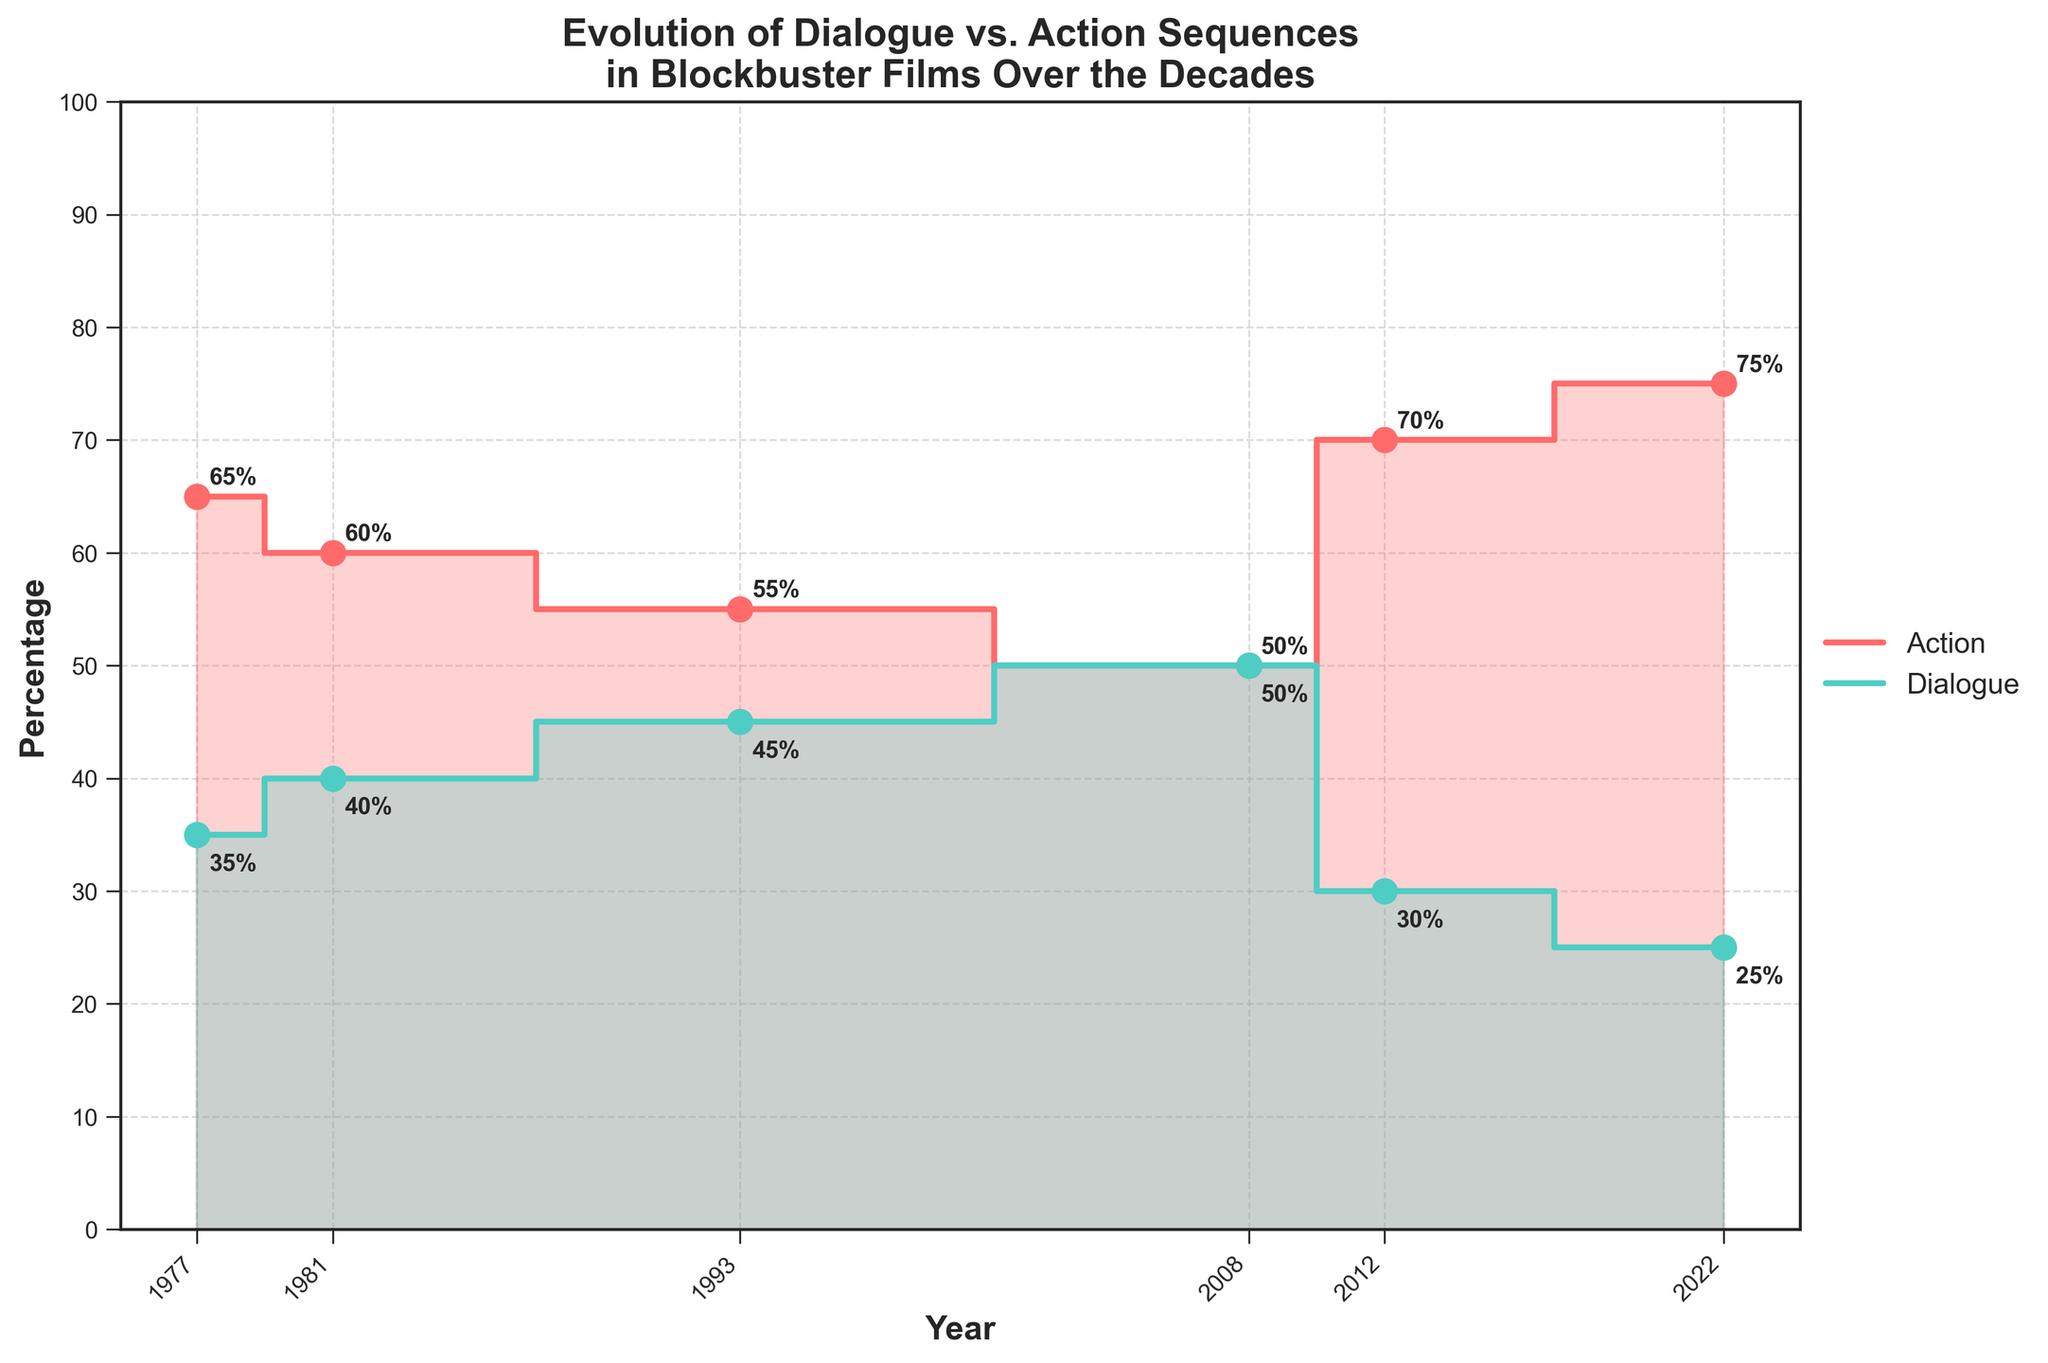What does the title of the plot indicate? The title of the plot is "Evolution of Dialogue vs. Action Sequences in Blockbuster Films Over the Decades". This indicates that the plot compares the percentage of dialogue and action sequences in blockbuster films throughout different decades.
Answer: Evolution of Dialogue vs. Action Sequences in Blockbuster Films Over the Decades What are the percentages of action and dialogue sequences in "The Dark Knight"? The percentages are represented by two points on the plot corresponding to the year 2008. The action sequences are at 50%, and the dialogue sequences are also at 50%.
Answer: 50% Action, 50% Dialogue How has the percentage of action sequences changed from the 1990s to the 2020s? To determine the change, look at the action sequence percentages for each decade. In the 1990s (1993), the percentage is 55%. In the 2020s (2022), the percentage is 75%. The percentage has increased by 20%.
Answer: Increased by 20% Which type of sequence has seen the highest percentage in the 2010s? In the 2010s (2012), compare the percentages of action and dialogue sequences. Action sequences are at 70%, while dialogue sequences are at 30%. Action sequences have seen the highest percentage.
Answer: Action How does the balance of action and dialogue sequences compare between "Star Wars" and "The Avengers"? Compare the two films by looking at their respective percentages. "Star Wars" has 65% action and 35% dialogue. "The Avengers" has 70% action and 30% dialogue. Both films have a higher percentage of action sequences, but "The Avengers" has slightly more action and slightly less dialogue compared to "Star Wars".
Answer: Both have more action, "The Avengers" has more What's the average percentage of dialogue scenes across all the films? To find the average, sum up the dialogue percentages for all the films and divide by the number of films. (35 + 40 + 45 + 50 + 30 + 25) / 6 = 225 / 6 = 37.5%
Answer: 37.5% Which film has the most balanced ratio of action to dialogue sequences? Look for the film where the percentages of action and dialogue are closest. "The Dark Knight" (2008) has 50% action and 50% dialogue, making it the most balanced.
Answer: The Dark Knight What is the trend in the percentage of dialogue scenes over the decades? Starting from the 1970s with "Star Wars" at 35%, then "Raiders of the Lost Ark" at 40%, "Jurassic Park" at 45%, "The Dark Knight" at 50%, "The Avengers" at 30%, and "Top Gun: Maverick" at 25%, the trend for dialogue sequences is a gradual decrease over the decades, with a slight increase in the early 2000s.
Answer: Gradual decrease Which decade shows the greatest increase in action sequences? Compare the decade intervals for the greatest increase. From the 2000s (2008) with 50%, to the 2010s (2012) with 70%, there's an increase of 20%. This is the largest increase observed.
Answer: From 2000s to 2010s What percentage difference between action and dialogue scenes is seen in "Top Gun: Maverick"? For "Top Gun: Maverick" in 2022, the percentages are 75% action and 25% dialogue. The difference is 75% - 25% = 50%.
Answer: 50% 